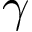<formula> <loc_0><loc_0><loc_500><loc_500>\gamma</formula> 